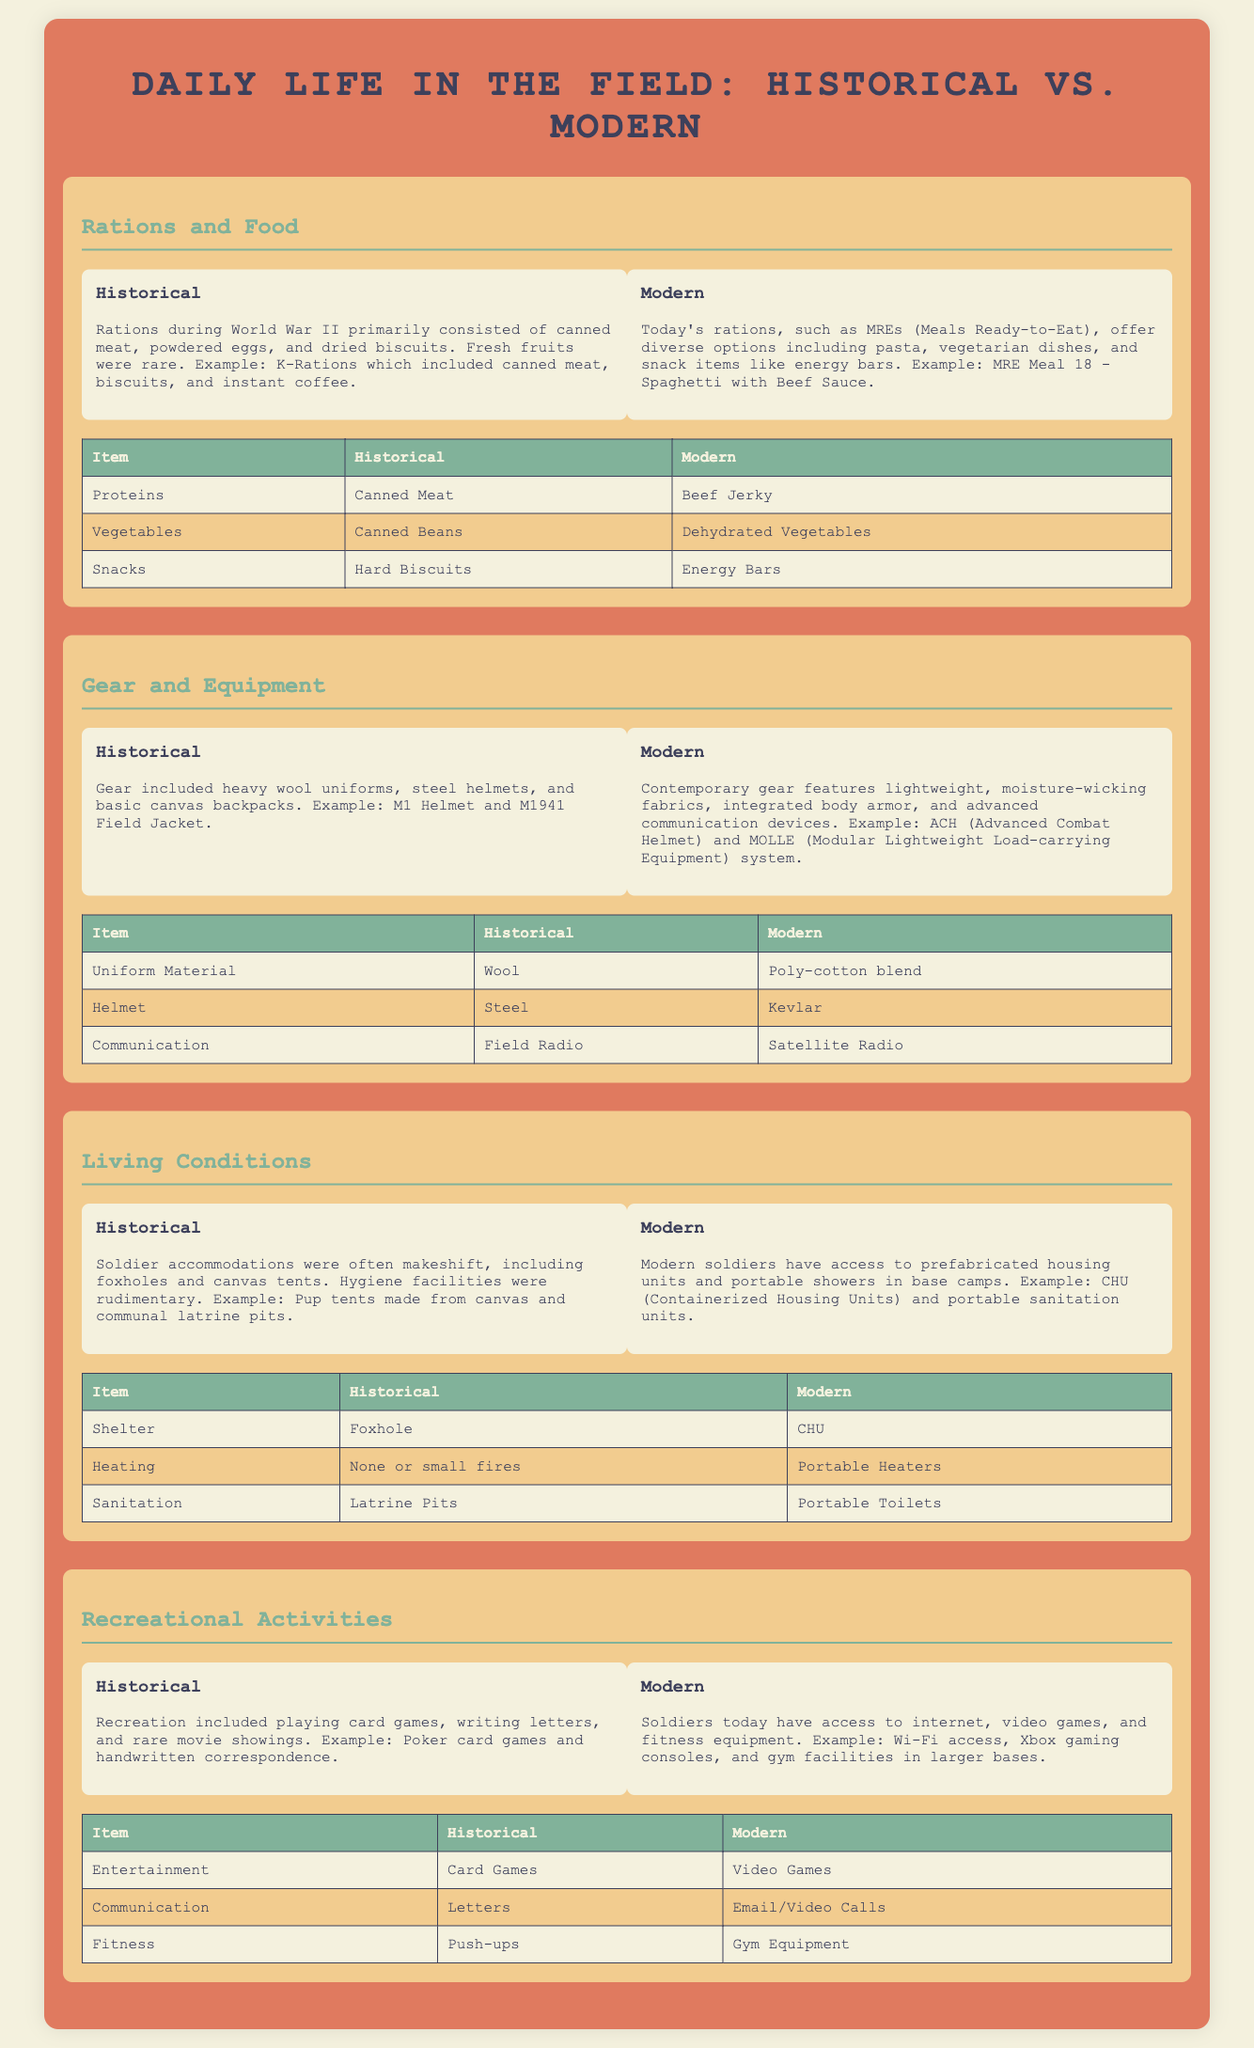What were the primary proteins in historical rations? The document lists canned meat as the primary protein in historical rations for soldiers.
Answer: Canned Meat What equipment was commonly used in the historical period? The document describes heavy wool uniforms, steel helmets, and basic canvas backpacks as common gear.
Answer: Heavy wool uniforms What type of shelter did historical soldiers use? The shelter listed for historical soldiers included foxholes and canvas tents.
Answer: Foxhole What is an example of a modern ration item? The document names MRE Meal 18 - Spaghetti with Beef Sauce as an example of a modern ration item.
Answer: MRE Meal 18 - Spaghetti with Beef Sauce How did soldiers communicate historically? According to the document, soldiers communicated through letters during the historical period.
Answer: Letters What recreational activity was common among historical soldiers? The document mentions card games as a common form of recreation among historical soldiers.
Answer: Card Games How does modern gear differ in terms of material? The document indicates that modern soldiers use a poly-cotton blend for their uniforms compared to wool in historical times.
Answer: Poly-cotton blend What is a modern equivalent for heating in soldier accommodations? The document provides that portable heaters are used in modern soldier accommodations.
Answer: Portable Heaters What form of entertainment is available to modern soldiers? The document states that video games are available for entertainment to modern soldiers.
Answer: Video Games 